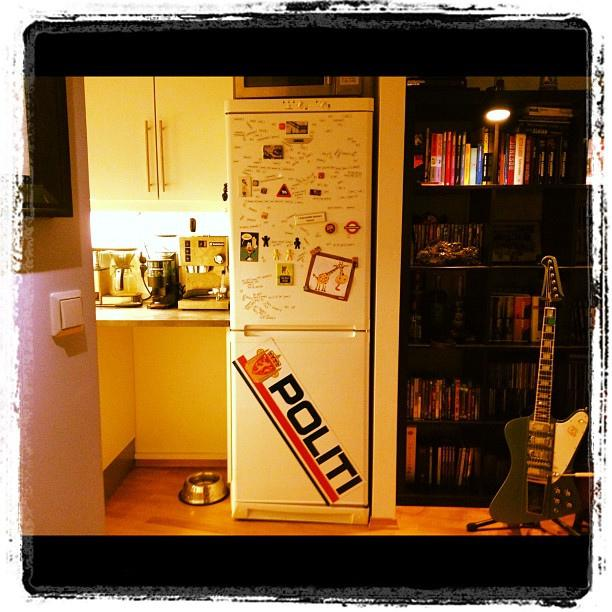In what nation is this apartment likely to be situated? Please explain your reasoning. denmark. The language that the sign on the fridge is written is that of the country. 